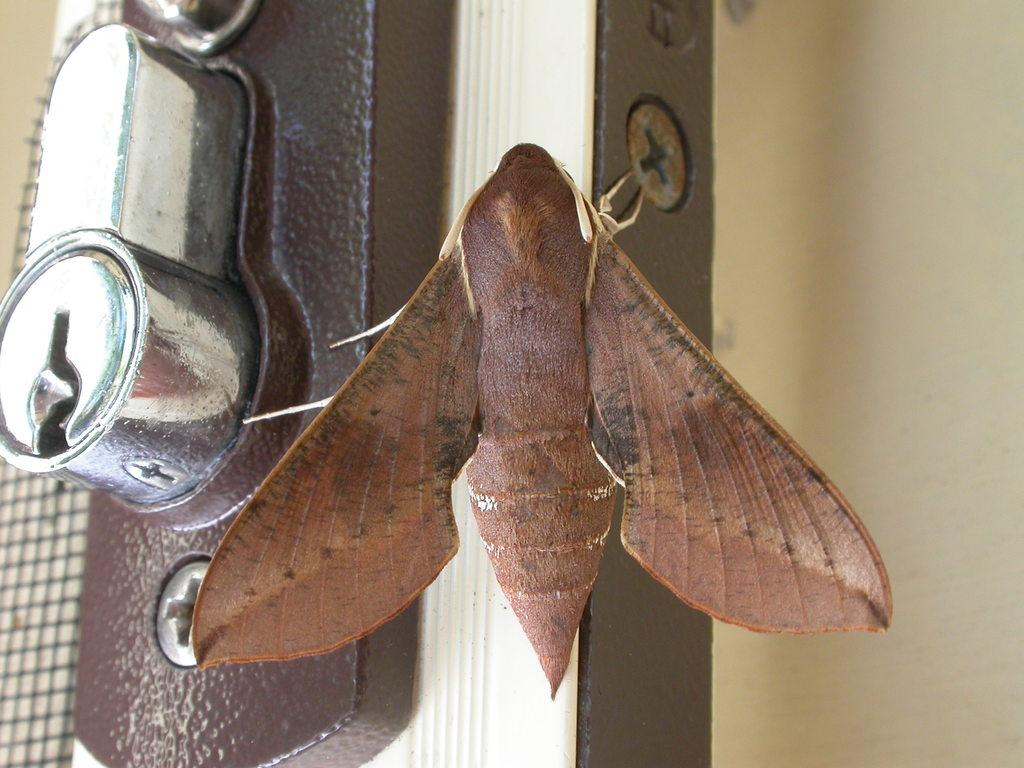What is the main subject in the center of the image? There is a moth in the center of the image. What is the moth standing on? The moth appears to be standing on a door. What can be seen on the left side of the image? There is a keyhole on the left side of the image. What is visible in the background of the image? There is a wall visible in the background of the image. How many boats are visible in the image? There are no boats present in the image. 